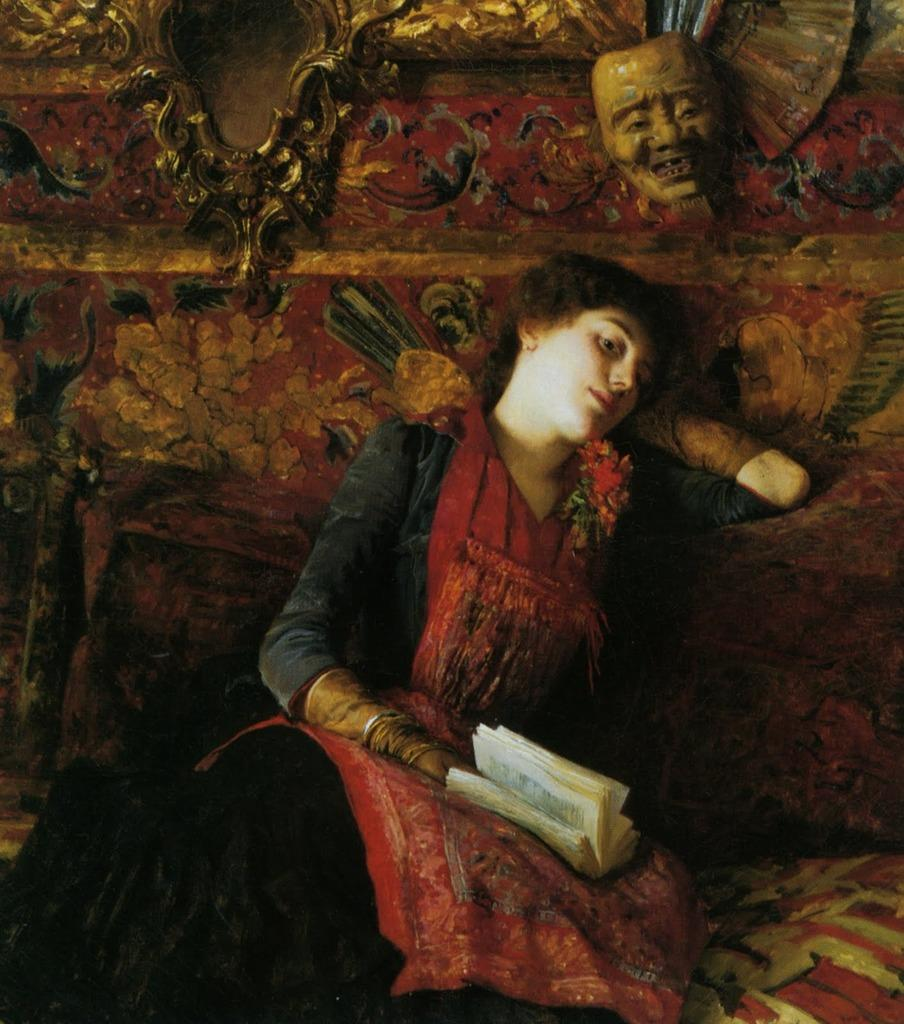Who is present in the image? There is a woman in the image. What is the woman doing in the image? The woman is sitting in the image. What is the woman holding in her hand? The woman is holding a book in her hand. What can be seen in the background of the image? There is a mask of a person in the background of the image. What type of image is this? The image is animated. What channel is the woman watching in the image? The image does not show the woman watching a channel, as it is not a live-action scene. 